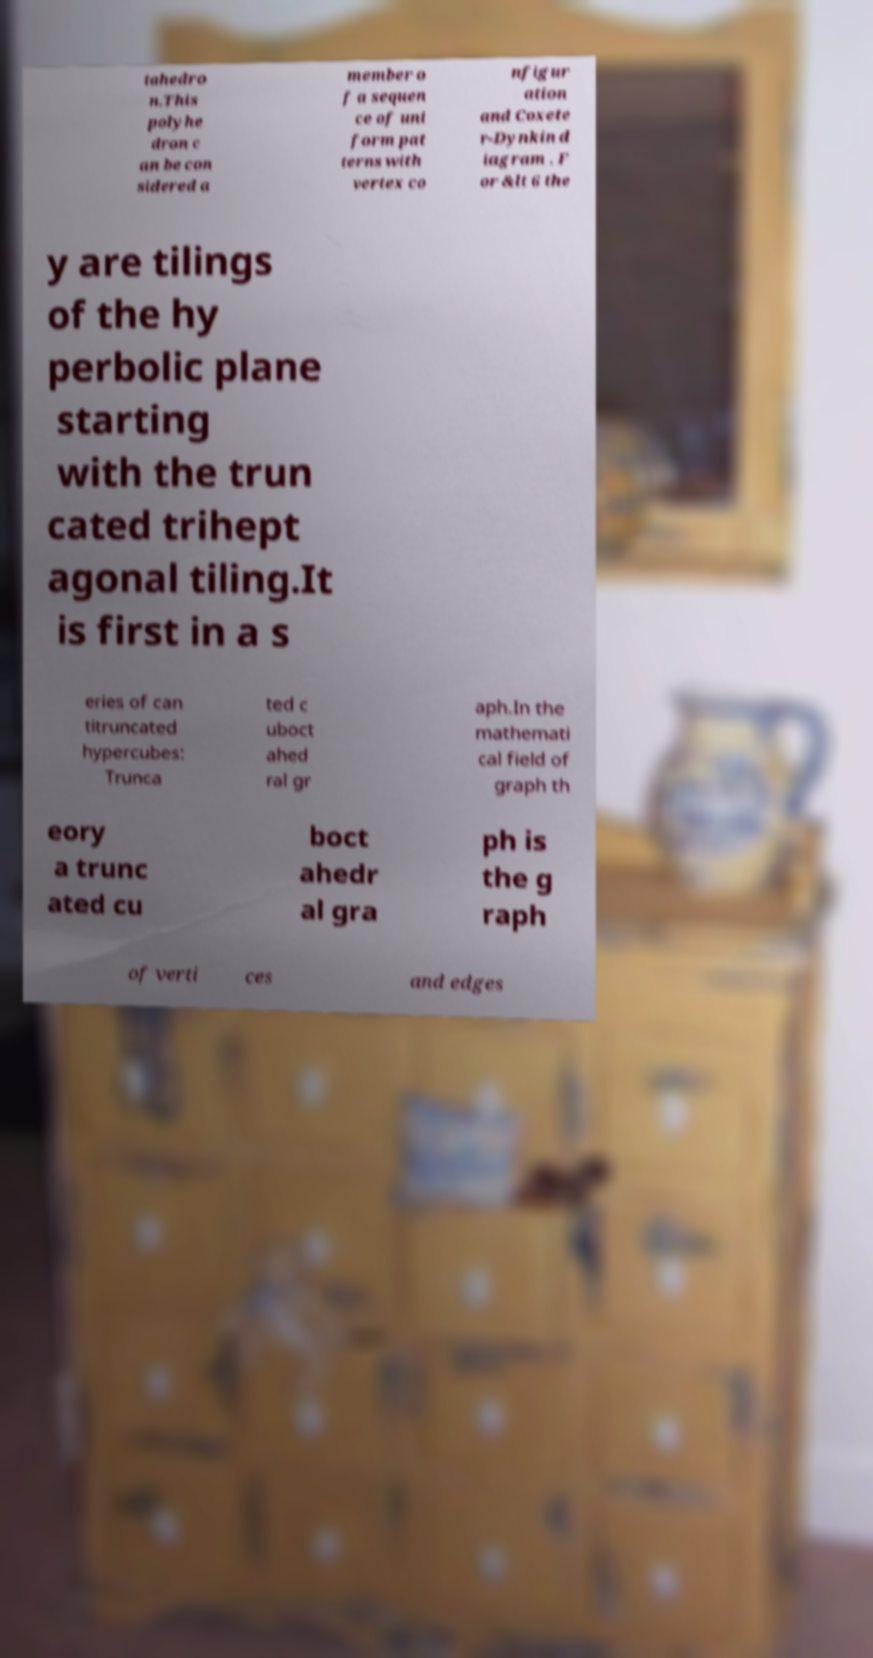For documentation purposes, I need the text within this image transcribed. Could you provide that? tahedro n.This polyhe dron c an be con sidered a member o f a sequen ce of uni form pat terns with vertex co nfigur ation and Coxete r-Dynkin d iagram . F or &lt 6 the y are tilings of the hy perbolic plane starting with the trun cated trihept agonal tiling.It is first in a s eries of can titruncated hypercubes: Trunca ted c uboct ahed ral gr aph.In the mathemati cal field of graph th eory a trunc ated cu boct ahedr al gra ph is the g raph of verti ces and edges 